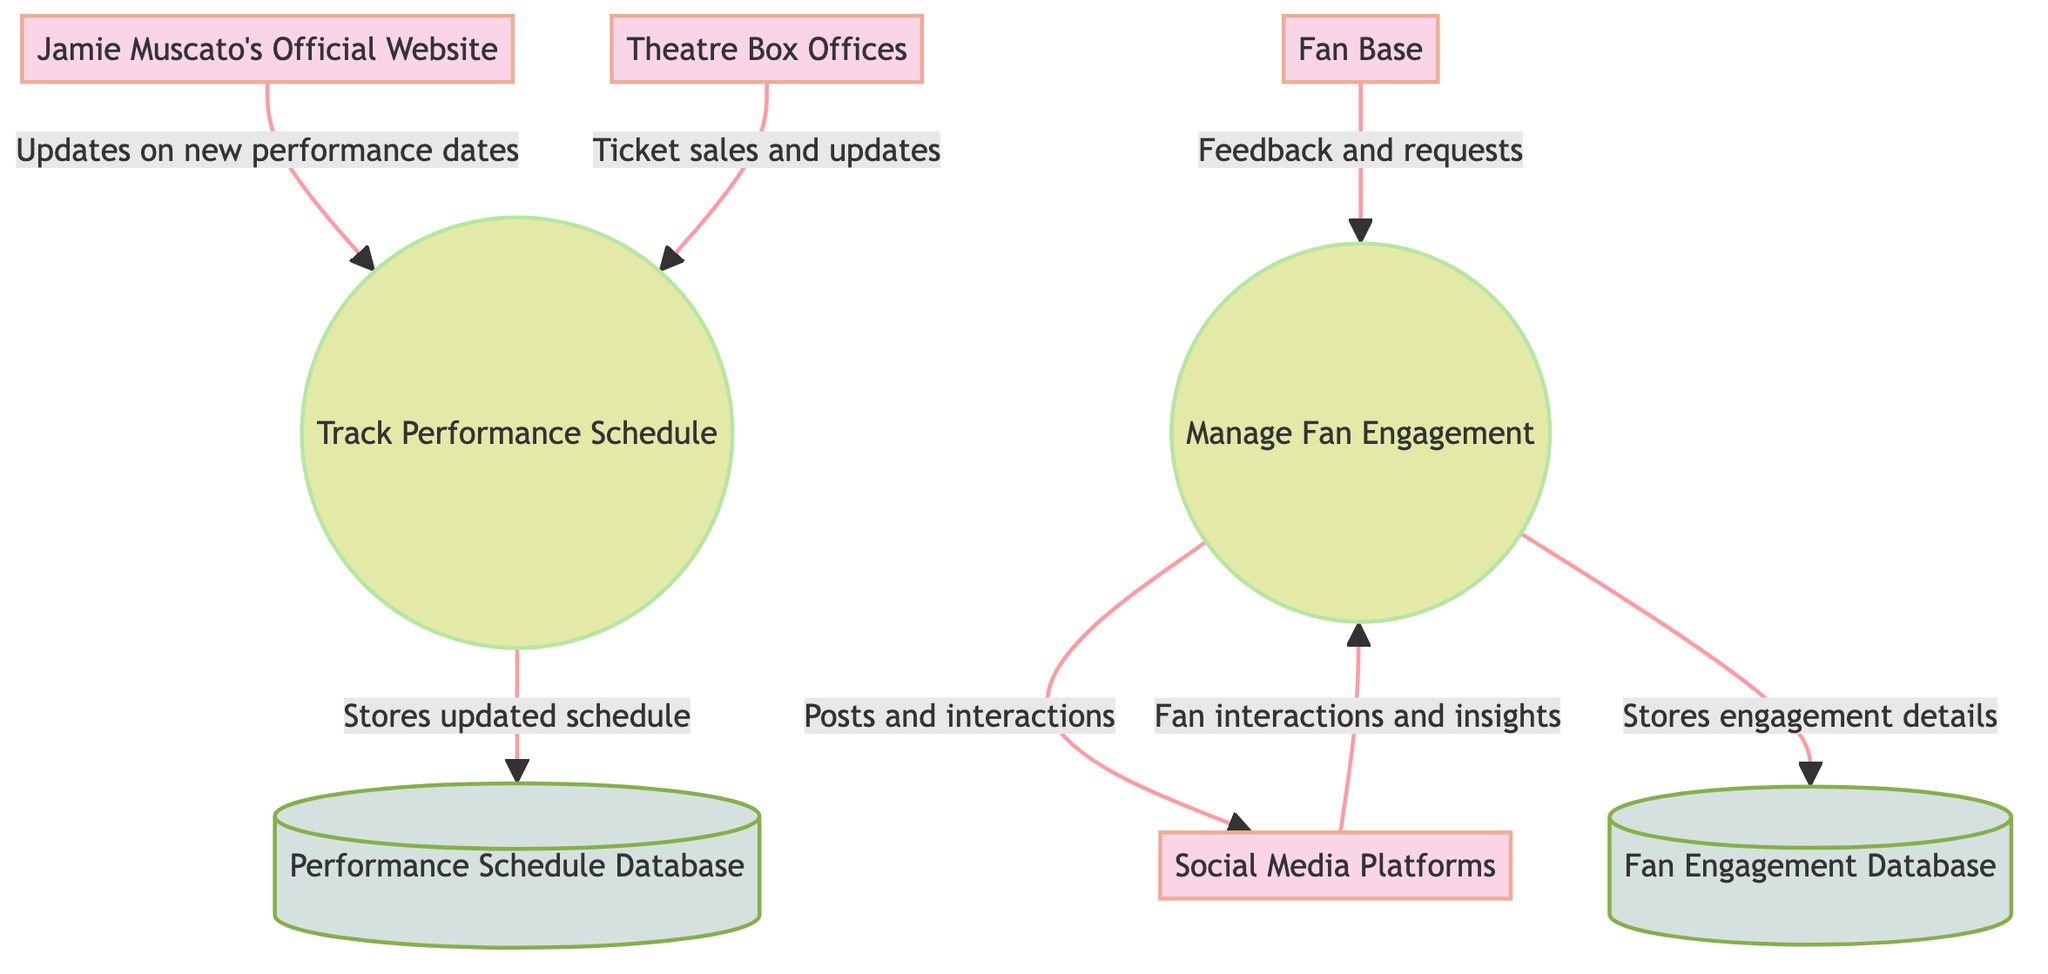What are the two main processes in the diagram? The diagram includes two main processes: "Track Performance Schedule" and "Manage Fan Engagement." These processes are clearly labeled and represent key functions in tracking Jamie Muscato's activities and interactions with fans.
Answer: Track Performance Schedule, Manage Fan Engagement How many data stores are present in the diagram? The diagram shows a total of two data stores: "Performance Schedule Database" and "Fan Engagement Database." These data stores are essential for keeping records of performance schedules and fan interactions.
Answer: 2 What is the source of updates for the performance schedule? The updates for the performance schedule come from "Jamie Muscato's Official Website," which is indicated as the primary source providing new performance dates and details to the "Track Performance Schedule" process.
Answer: Jamie Muscato's Official Website Which process stores details about fan engagement activities? The process responsible for storing details about fan engagement activities is "Manage Fan Engagement." It sends information to the "Fan Engagement Database" for this purpose.
Answer: Manage Fan Engagement What do the Theatre Box Offices provide to the Track Performance Schedule process? The Theatre Box Offices provide "ticket sales and updates," which are crucial for keeping the performance schedule accurate and up-to-date within the "Track Performance Schedule" process.
Answer: Ticket sales and updates How does the Fan Base interact with the Manage Fan Engagement process? The Fan Base interacts with the Manage Fan Engagement process by providing feedback and requests for fan activities, which indicates their active participation in shaping engagement strategies.
Answer: Feedback and requests What kind of data is stored in the Performance Schedule Database? The Performance Schedule Database stores "information about upcoming performances, including dates, venues, and show details," serving as a comprehensive archive of Jamie Muscato's performance schedule.
Answer: Information about upcoming performances What is the relationship between Social Media Platforms and Manage Fan Engagement? The Social Media Platforms are involved in two-way communication with "Manage Fan Engagement": they receive posts and interactions to engage fans and provide insights back to the process based on fan interactions.
Answer: Two-way communication Which arrows indicate the flow of information from the data stores? The arrows from "Performance Schedule Database" and "Fan Engagement Database" show where information flows from these data stores, indicating how these databases feed back into their respective processes.
Answer: Arrows from data stores 